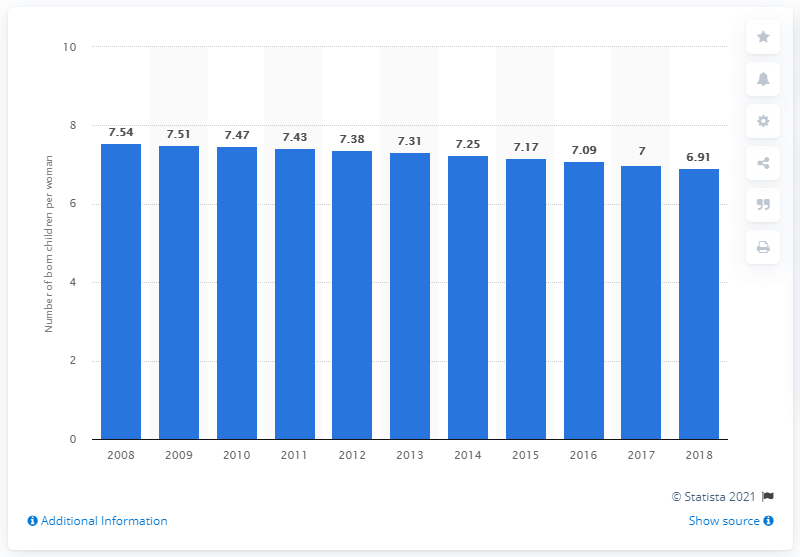Identify some key points in this picture. In 2018, the fertility rate in Niger was 6.91. 